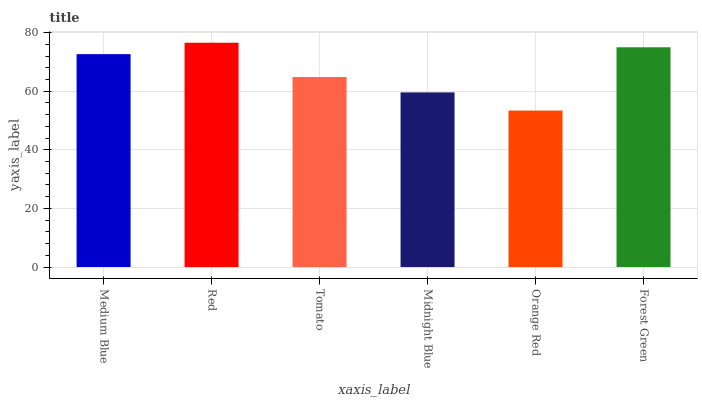Is Tomato the minimum?
Answer yes or no. No. Is Tomato the maximum?
Answer yes or no. No. Is Red greater than Tomato?
Answer yes or no. Yes. Is Tomato less than Red?
Answer yes or no. Yes. Is Tomato greater than Red?
Answer yes or no. No. Is Red less than Tomato?
Answer yes or no. No. Is Medium Blue the high median?
Answer yes or no. Yes. Is Tomato the low median?
Answer yes or no. Yes. Is Red the high median?
Answer yes or no. No. Is Midnight Blue the low median?
Answer yes or no. No. 